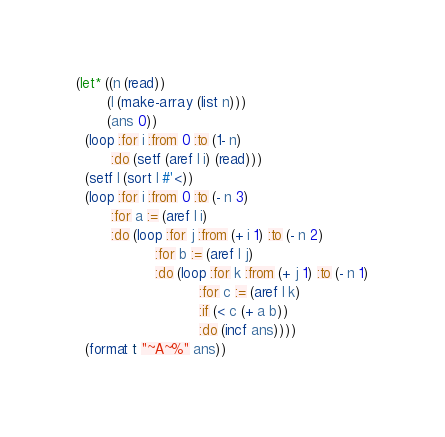<code> <loc_0><loc_0><loc_500><loc_500><_Lisp_>(let* ((n (read))
       (l (make-array (list n)))
       (ans 0))
  (loop :for i :from 0 :to (1- n)
        :do (setf (aref l i) (read)))
  (setf l (sort l #'<))
  (loop :for i :from 0 :to (- n 3)
        :for a := (aref l i)
        :do (loop :for j :from (+ i 1) :to (- n 2)
                  :for b := (aref l j)
                  :do (loop :for k :from (+ j 1) :to (- n 1)
                            :for c := (aref l k)
                            :if (< c (+ a b))
                            :do (incf ans))))
  (format t "~A~%" ans))
</code> 